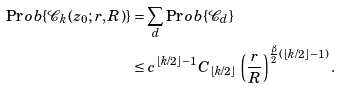Convert formula to latex. <formula><loc_0><loc_0><loc_500><loc_500>\Pr o b \{ \mathcal { C } _ { k } ( z _ { 0 } ; r , R ) \} & = \sum _ { d } \Pr o b \{ \mathcal { C } _ { d } \} \\ & \leq c ^ { \lfloor k / 2 \rfloor - 1 } C _ { \lfloor k / 2 \rfloor } \, \left ( \frac { r } { R } \right ) ^ { \frac { \beta } { 2 } ( \lfloor k / 2 \rfloor - 1 ) } .</formula> 